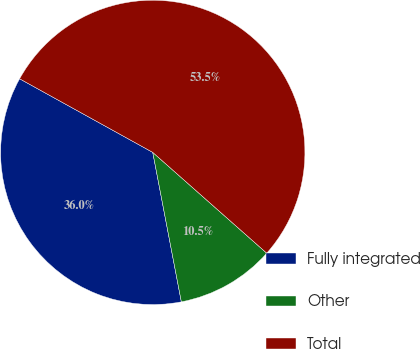Convert chart. <chart><loc_0><loc_0><loc_500><loc_500><pie_chart><fcel>Fully integrated<fcel>Other<fcel>Total<nl><fcel>36.05%<fcel>10.47%<fcel>53.49%<nl></chart> 